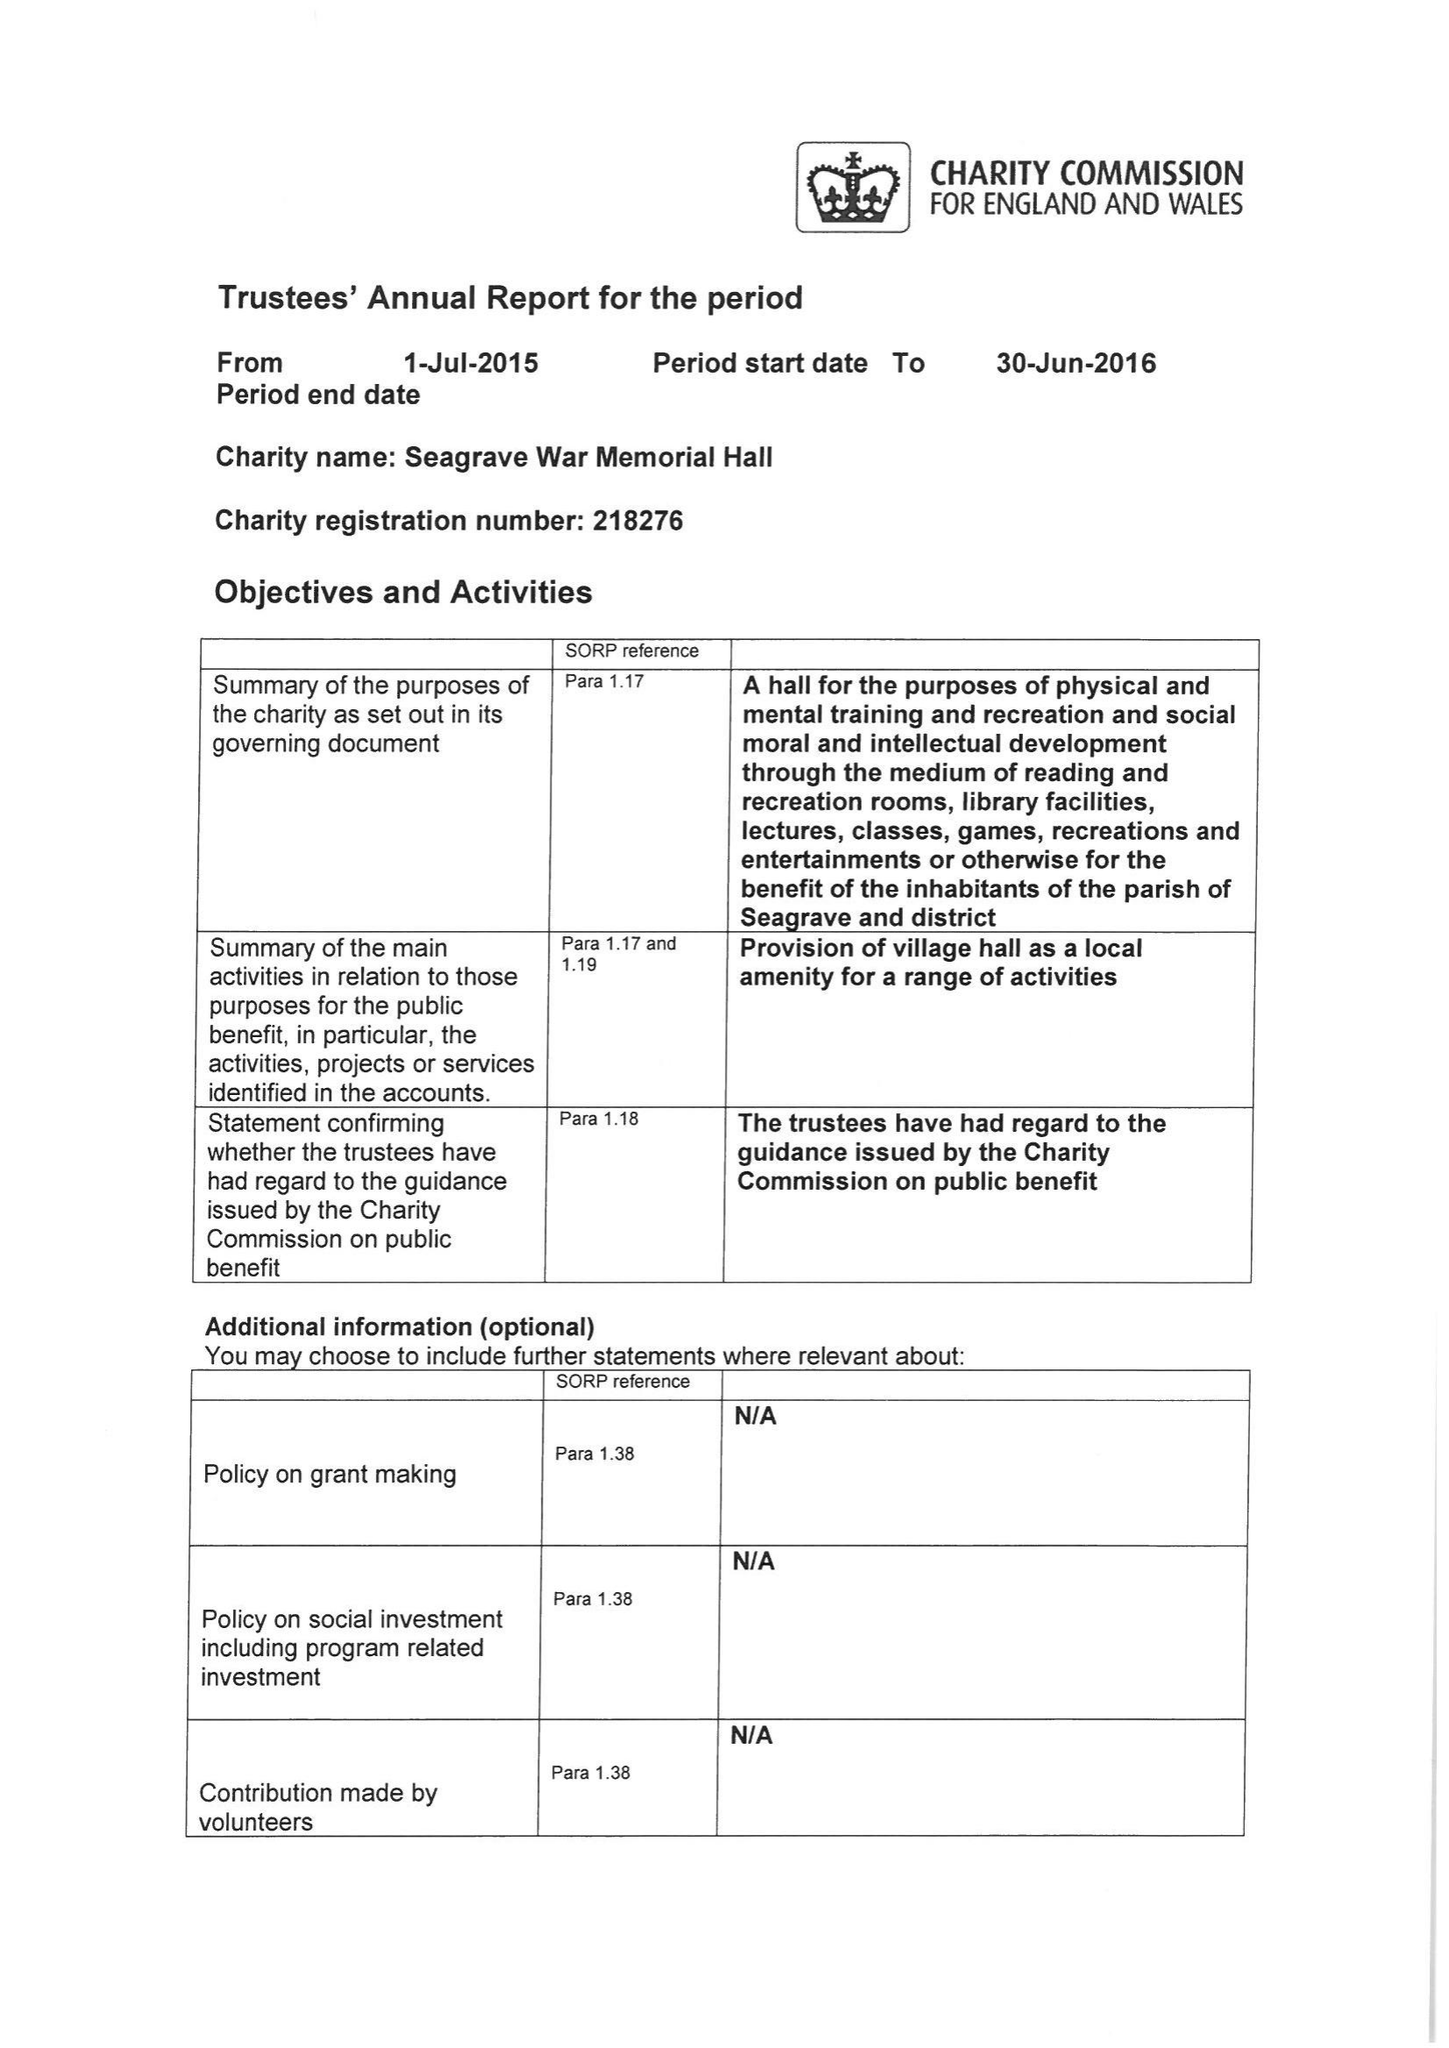What is the value for the income_annually_in_british_pounds?
Answer the question using a single word or phrase. 27279.65 